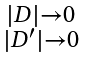<formula> <loc_0><loc_0><loc_500><loc_500>\begin{smallmatrix} | D | \to 0 \\ | D ^ { \prime } | \to 0 \end{smallmatrix}</formula> 